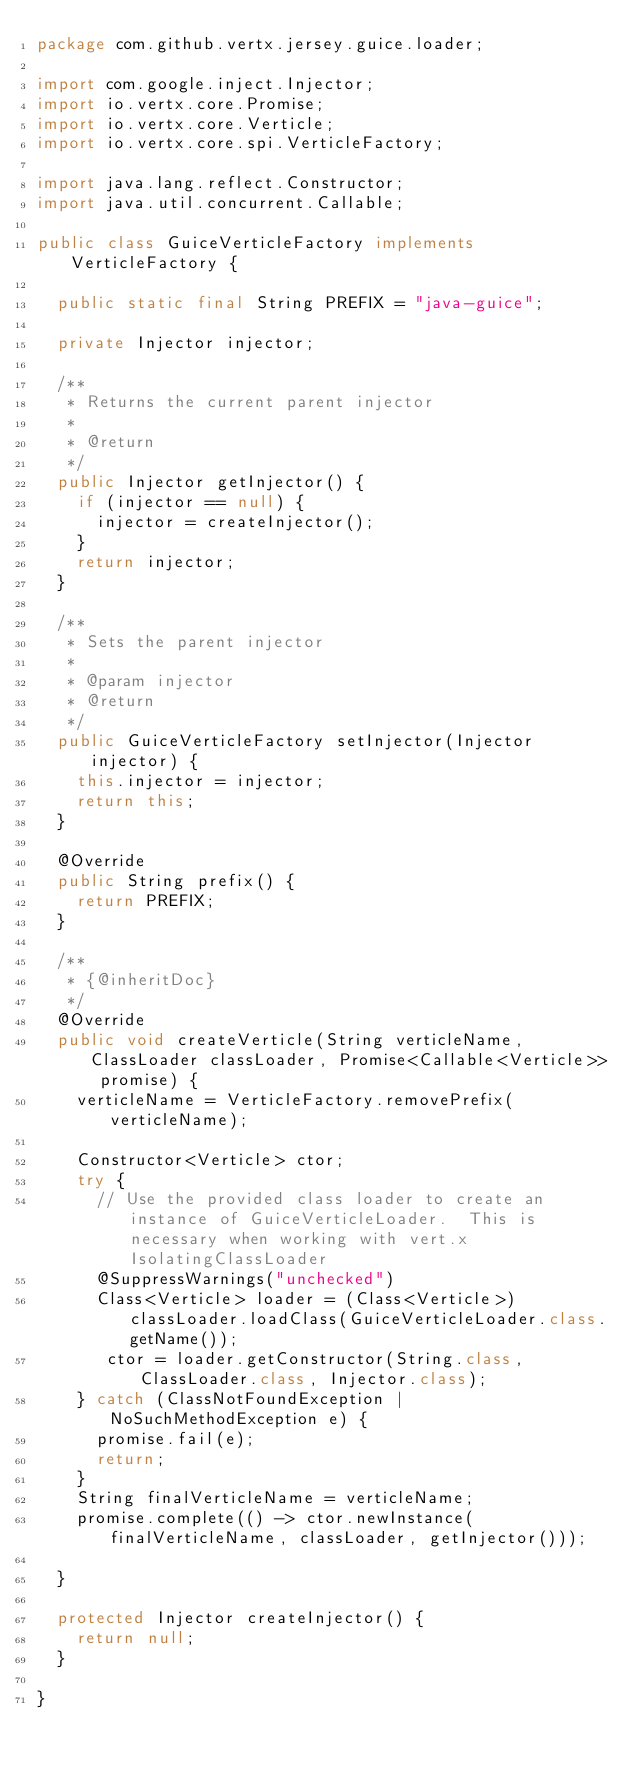<code> <loc_0><loc_0><loc_500><loc_500><_Java_>package com.github.vertx.jersey.guice.loader;

import com.google.inject.Injector;
import io.vertx.core.Promise;
import io.vertx.core.Verticle;
import io.vertx.core.spi.VerticleFactory;

import java.lang.reflect.Constructor;
import java.util.concurrent.Callable;

public class GuiceVerticleFactory implements VerticleFactory {

  public static final String PREFIX = "java-guice";

  private Injector injector;

  /**
   * Returns the current parent injector
   *
   * @return
   */
  public Injector getInjector() {
    if (injector == null) {
      injector = createInjector();
    }
    return injector;
  }

  /**
   * Sets the parent injector
   *
   * @param injector
   * @return
   */
  public GuiceVerticleFactory setInjector(Injector injector) {
    this.injector = injector;
    return this;
  }

  @Override
  public String prefix() {
    return PREFIX;
  }

  /**
   * {@inheritDoc}
   */
  @Override
  public void createVerticle(String verticleName, ClassLoader classLoader, Promise<Callable<Verticle>> promise) {
    verticleName = VerticleFactory.removePrefix(verticleName);

    Constructor<Verticle> ctor;
    try {
      // Use the provided class loader to create an instance of GuiceVerticleLoader.  This is necessary when working with vert.x IsolatingClassLoader
      @SuppressWarnings("unchecked")
      Class<Verticle> loader = (Class<Verticle>) classLoader.loadClass(GuiceVerticleLoader.class.getName());
       ctor = loader.getConstructor(String.class, ClassLoader.class, Injector.class);
    } catch (ClassNotFoundException | NoSuchMethodException e) {
      promise.fail(e);
      return;
    }
    String finalVerticleName = verticleName;
    promise.complete(() -> ctor.newInstance(finalVerticleName, classLoader, getInjector()));

  }

  protected Injector createInjector() {
    return null;
  }

}
</code> 